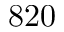Convert formula to latex. <formula><loc_0><loc_0><loc_500><loc_500>8 2 0</formula> 